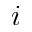<formula> <loc_0><loc_0><loc_500><loc_500>i</formula> 